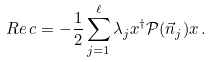<formula> <loc_0><loc_0><loc_500><loc_500>R e \, c = - \frac { 1 } { 2 } \sum _ { j = 1 } ^ { \ell } \lambda _ { j } x ^ { \dagger } \mathcal { P } ( \vec { n } _ { j } ) x \, .</formula> 